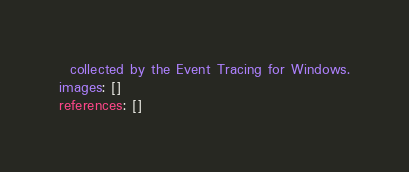Convert code to text. <code><loc_0><loc_0><loc_500><loc_500><_YAML_>  collected by the Event Tracing for Windows.
images: []
references: []
</code> 